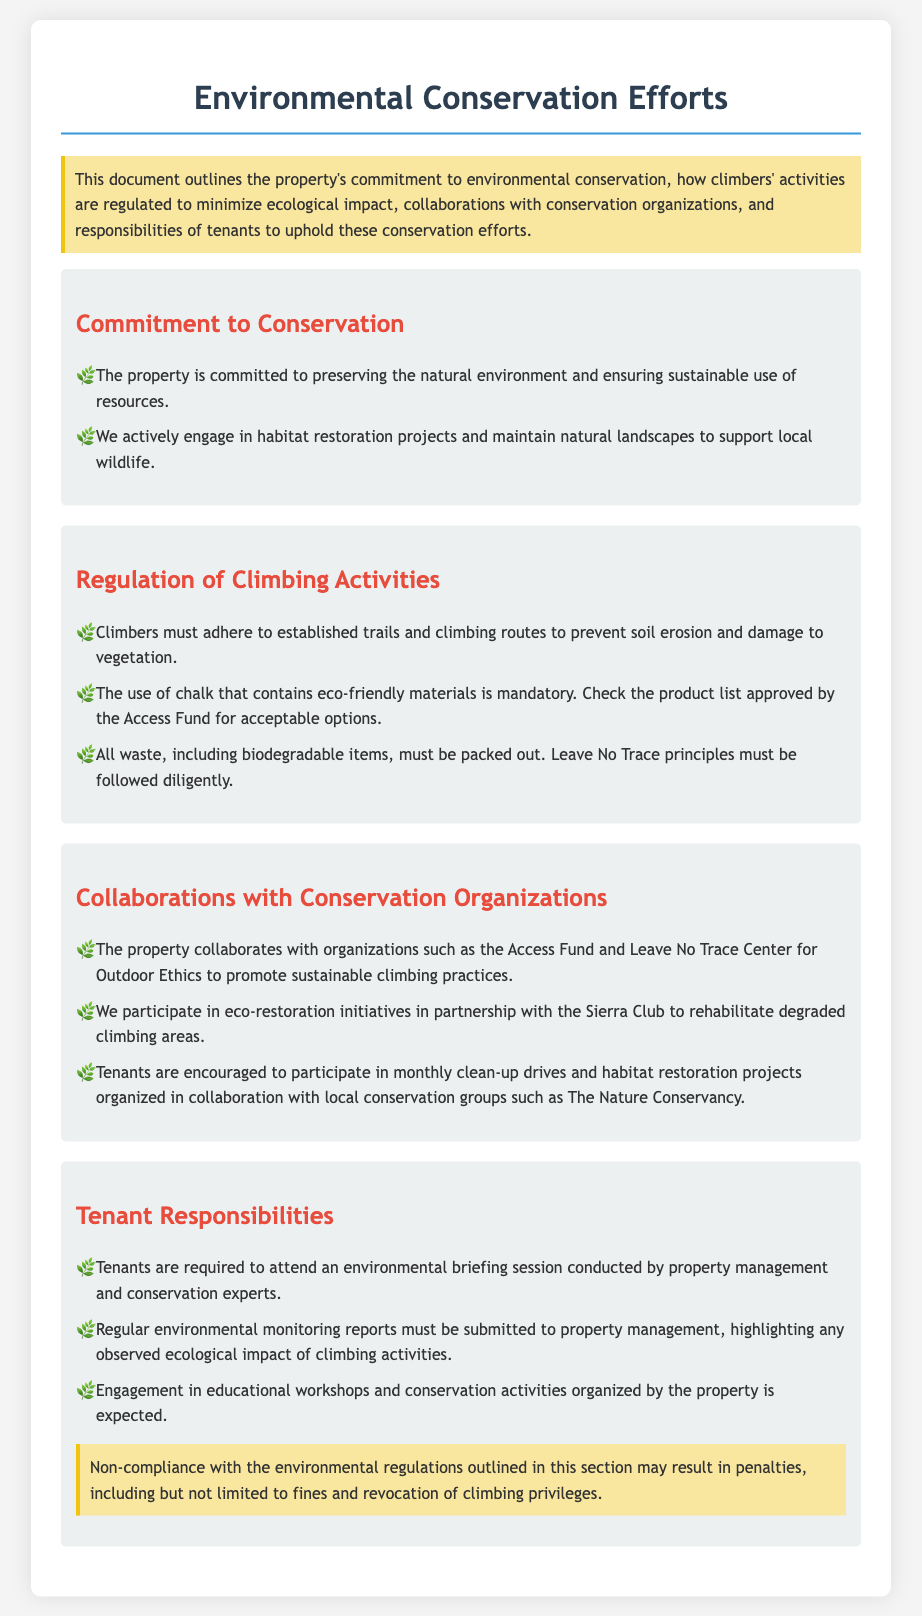What is the property’s commitment to environmental conservation? The document outlines the property’s commitment to preserving the natural environment and ensuring sustainable use of resources.
Answer: Preserving the natural environment and ensuring sustainable use of resources What must climbers do to prevent soil erosion? Climbers are required to adhere to established trails and climbing routes to prevent soil erosion and damage to vegetation.
Answer: Adhere to established trails and climbing routes Which organization requires the use of eco-friendly chalk? Climbers must check the product list approved by the Access Fund for acceptable eco-friendly chalk options.
Answer: Access Fund What kind of principles must climbers follow regarding waste? All waste, including biodegradable items, must be packed out, and Leave No Trace principles must be followed diligently.
Answer: Leave No Trace principles What type of activities are tenants encouraged to participate in with local conservation groups? Tenants are encouraged to participate in monthly clean-up drives and habitat restoration projects organized in collaboration with local conservation groups.
Answer: Monthly clean-up drives and habitat restoration projects How many responsibilities are listed for tenants in relation to conservation efforts? There are three specific responsibilities required of tenants to uphold conservation efforts outlined in the document.
Answer: Three What is a penalty for non-compliance with environmental regulations? Non-compliance may result in penalties including fines and revocation of climbing privileges.
Answer: Fines and revocation of climbing privileges 